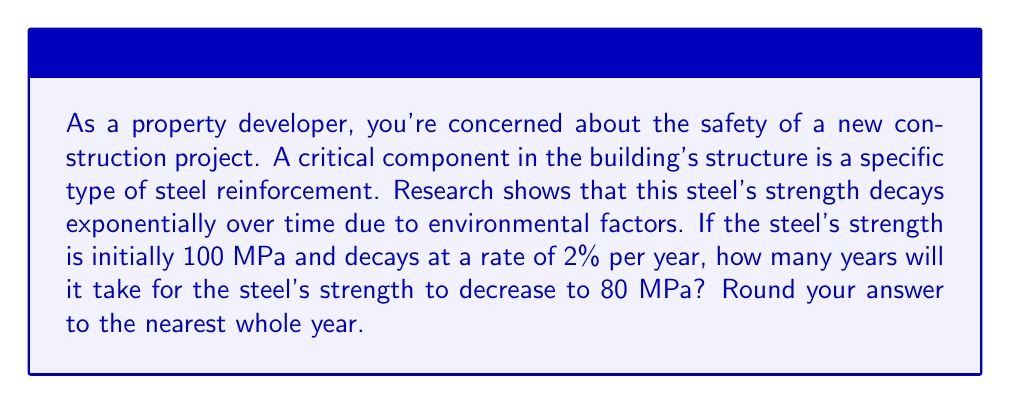Help me with this question. Let's approach this step-by-step using an exponential decay function:

1) The general form of exponential decay is:
   $A(t) = A_0 \cdot (1-r)^t$

   Where:
   $A(t)$ is the amount at time $t$
   $A_0$ is the initial amount
   $r$ is the decay rate per unit time
   $t$ is the time

2) We know:
   $A_0 = 100$ MPa (initial strength)
   $r = 0.02$ (2% decay rate)
   $A(t) = 80$ MPa (final strength we're solving for)

3) Let's plug these into our equation:
   $80 = 100 \cdot (1-0.02)^t$

4) Simplify:
   $80 = 100 \cdot (0.98)^t$

5) Divide both sides by 100:
   $0.8 = (0.98)^t$

6) Take the natural log of both sides:
   $\ln(0.8) = \ln((0.98)^t)$

7) Use the log property $\ln(a^b) = b\ln(a)$:
   $\ln(0.8) = t \cdot \ln(0.98)$

8) Solve for $t$:
   $t = \frac{\ln(0.8)}{\ln(0.98)} \approx 11.16$ years

9) Rounding to the nearest whole year:
   $t \approx 11$ years
Answer: 11 years 